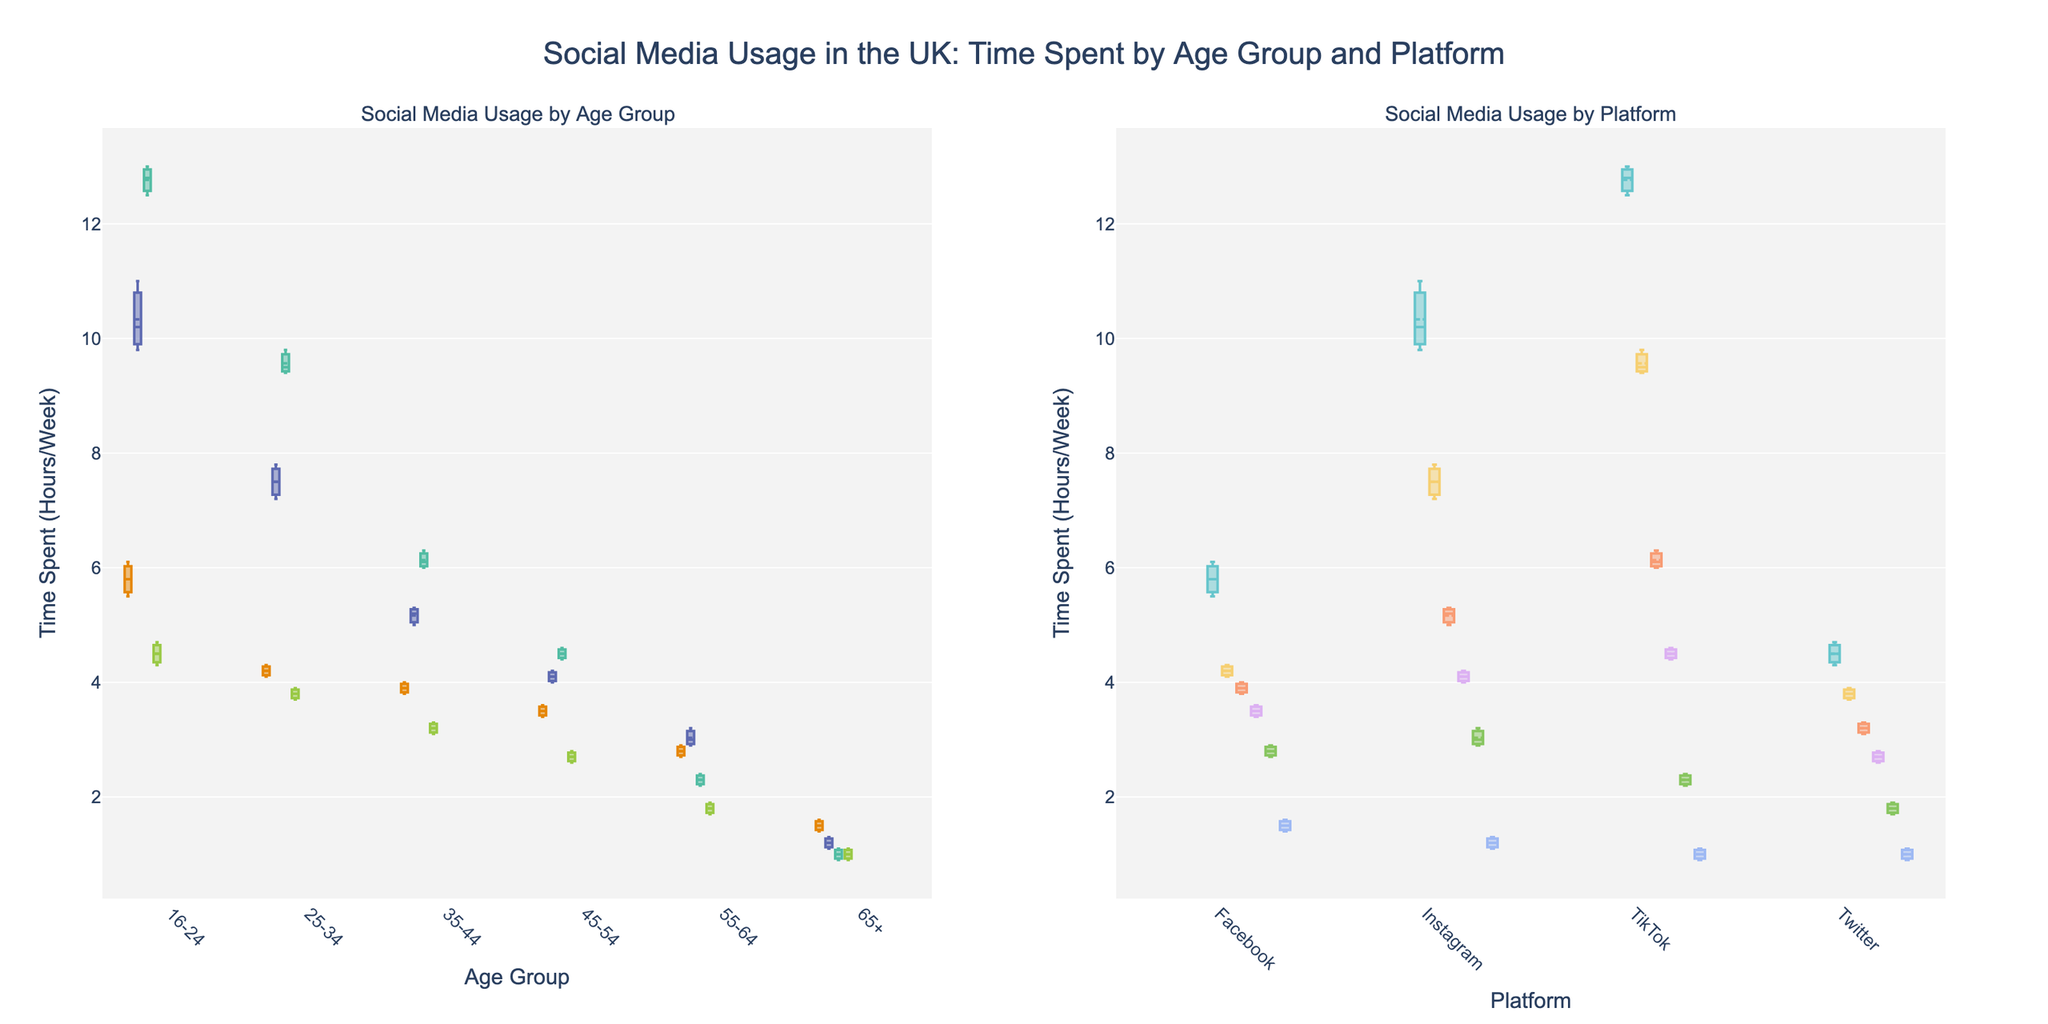What are the titles of the subplots in the figure? The figure has two subplots. The titles are directly above the subplots and read "Social Media Usage by Age Group" and "Social Media Usage by Platform".
Answer: Social Media Usage by Age Group, Social Media Usage by Platform Which age group spends the most time on TikTok on average? By observing the box plots, the 16-24 age group has the highest median value for TikTok, indicating they spend the most time on average on TikTok.
Answer: 16-24 For the Instagram platform, which age group has the smallest interquartile range (IQR)? The interquartile range can be observed by the length of the box in the box plot. The 65+ age group's box for Instagram is the smallest, indicating the smallest IQR.
Answer: 65+ How does the median time spent on Facebook compare between the 16-24 age group and the 65+ age group? The median is represented by the line inside each box. The 16-24 age group's median time on Facebook is significantly higher than the 65+ age group's median time.
Answer: 16-24 > 65+ What is the range of time spent on Twitter by the 45-54 age group? The range is determined by the whiskers of the box plot. For the 45-54 age group's Twitter usage, the minimum is 2.6 hours/week and the maximum is 2.8 hours/week. Therefore, the range is 2.8 - 2.6 = 0.2 hours.
Answer: 0.2 hours Which platform shows the most consistent usage across all age groups? Consistent usage can be inferred from the size of the boxes and length of the whiskers. Twitter has relatively smaller boxes and shorter whiskers across all age groups compared to other platforms.
Answer: Twitter Is the median time spent on Instagram higher in the 25-34 age group compared to the 35-44 age group? By examining the medians (lines within the boxes), the median time for the 25-34 age group is higher than that of the 35-44 age group on Instagram.
Answer: Yes Describe the difference in the usage trends of TikTok between the youngest (16-24) and oldest (65+) age groups. The 16-24 age group shows a much higher median value and generally higher usage (position and scale of the box plot) compared to the 65+ age group, which has a very low usage.
Answer: 16-24 much higher than 65+ On which platform is the mean time spent most different from the median time spent across all age groups? The mean time spent can be inferred from the marker inside each box plot. TikTok shows noticeable differences between the mean (dots) and the median (lines), especially in the younger age groups.
Answer: TikTok 